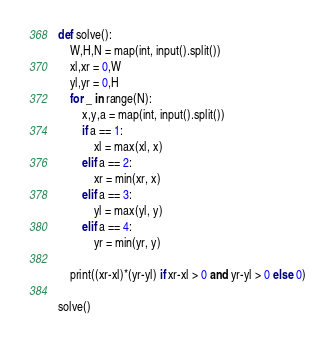<code> <loc_0><loc_0><loc_500><loc_500><_Python_>def solve():
    W,H,N = map(int, input().split())
    xl,xr = 0,W
    yl,yr = 0,H
    for _ in range(N):
        x,y,a = map(int, input().split())
        if a == 1:
            xl = max(xl, x)
        elif a == 2:
            xr = min(xr, x)
        elif a == 3:
            yl = max(yl, y)
        elif a == 4:
            yr = min(yr, y)
    
    print((xr-xl)*(yr-yl) if xr-xl > 0 and yr-yl > 0 else 0)
    
solve()</code> 